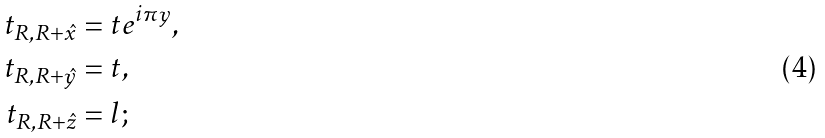Convert formula to latex. <formula><loc_0><loc_0><loc_500><loc_500>t _ { R , R + \hat { x } } & = t e ^ { i \pi y } , \\ t _ { R , R + \hat { y } } & = t , \\ t _ { R , R + \hat { z } } & = l ;</formula> 